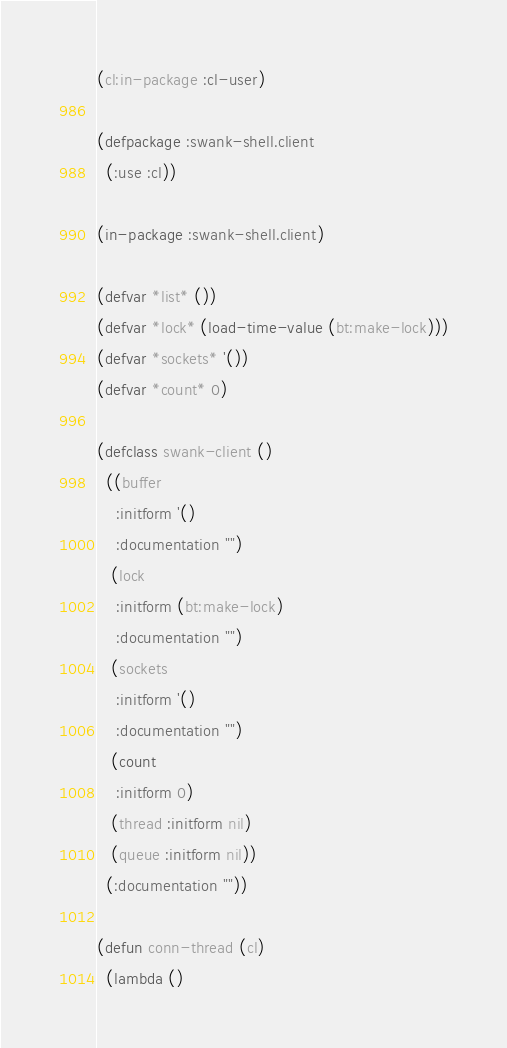Convert code to text. <code><loc_0><loc_0><loc_500><loc_500><_Lisp_>(cl:in-package :cl-user)

(defpackage :swank-shell.client
  (:use :cl))

(in-package :swank-shell.client)

(defvar *list* ())
(defvar *lock* (load-time-value (bt:make-lock)))
(defvar *sockets* '())
(defvar *count* 0)

(defclass swank-client ()
  ((buffer
    :initform '()
    :documentation "")
   (lock
    :initform (bt:make-lock)
    :documentation "")
   (sockets
    :initform '()
    :documentation "")
   (count
    :initform 0)
   (thread :initform nil)
   (queue :initform nil))
  (:documentation ""))

(defun conn-thread (cl)
  (lambda ()</code> 